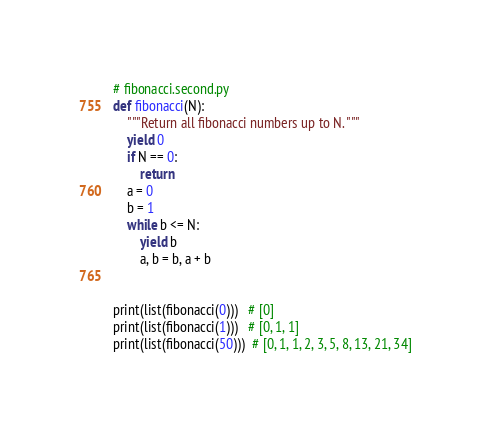<code> <loc_0><loc_0><loc_500><loc_500><_Python_># fibonacci.second.py
def fibonacci(N):
    """Return all fibonacci numbers up to N. """
    yield 0
    if N == 0:
        return
    a = 0
    b = 1
    while b <= N:
        yield b
        a, b = b, a + b


print(list(fibonacci(0)))   # [0]
print(list(fibonacci(1)))   # [0, 1, 1]
print(list(fibonacci(50)))  # [0, 1, 1, 2, 3, 5, 8, 13, 21, 34]
</code> 